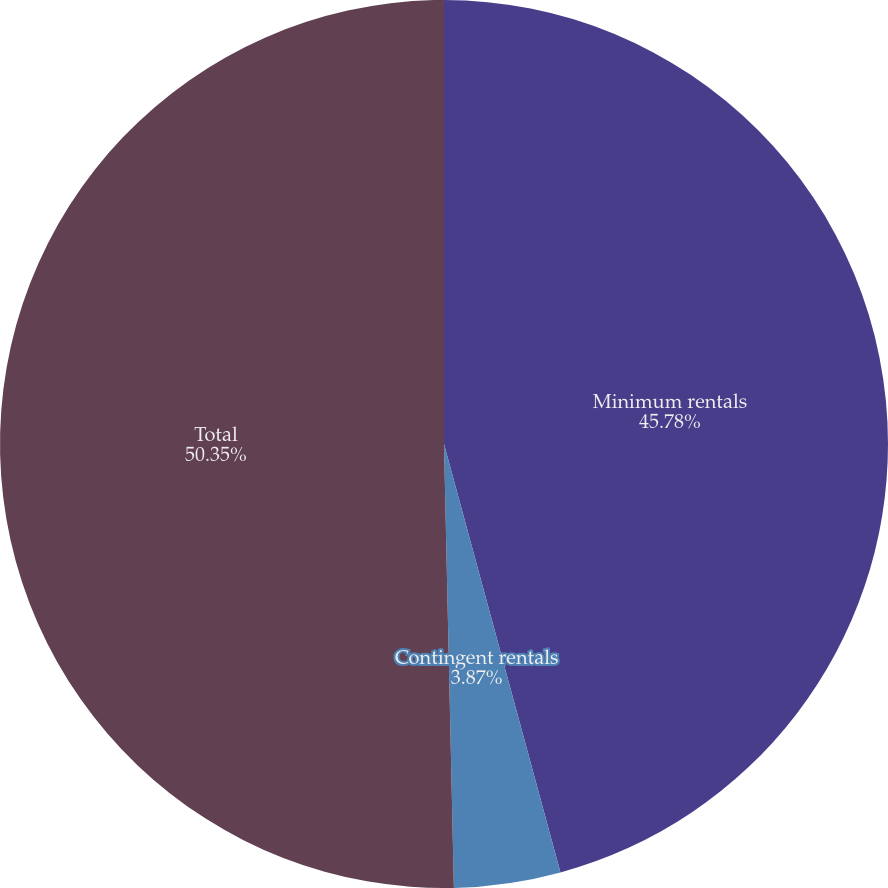Convert chart to OTSL. <chart><loc_0><loc_0><loc_500><loc_500><pie_chart><fcel>Minimum rentals<fcel>Contingent rentals<fcel>Total<nl><fcel>45.78%<fcel>3.87%<fcel>50.36%<nl></chart> 